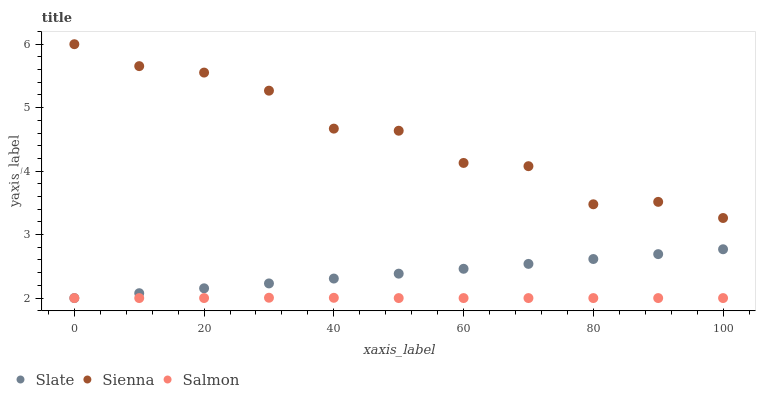Does Salmon have the minimum area under the curve?
Answer yes or no. Yes. Does Sienna have the maximum area under the curve?
Answer yes or no. Yes. Does Slate have the minimum area under the curve?
Answer yes or no. No. Does Slate have the maximum area under the curve?
Answer yes or no. No. Is Slate the smoothest?
Answer yes or no. Yes. Is Sienna the roughest?
Answer yes or no. Yes. Is Salmon the smoothest?
Answer yes or no. No. Is Salmon the roughest?
Answer yes or no. No. Does Slate have the lowest value?
Answer yes or no. Yes. Does Sienna have the highest value?
Answer yes or no. Yes. Does Slate have the highest value?
Answer yes or no. No. Is Salmon less than Sienna?
Answer yes or no. Yes. Is Sienna greater than Slate?
Answer yes or no. Yes. Does Salmon intersect Slate?
Answer yes or no. Yes. Is Salmon less than Slate?
Answer yes or no. No. Is Salmon greater than Slate?
Answer yes or no. No. Does Salmon intersect Sienna?
Answer yes or no. No. 